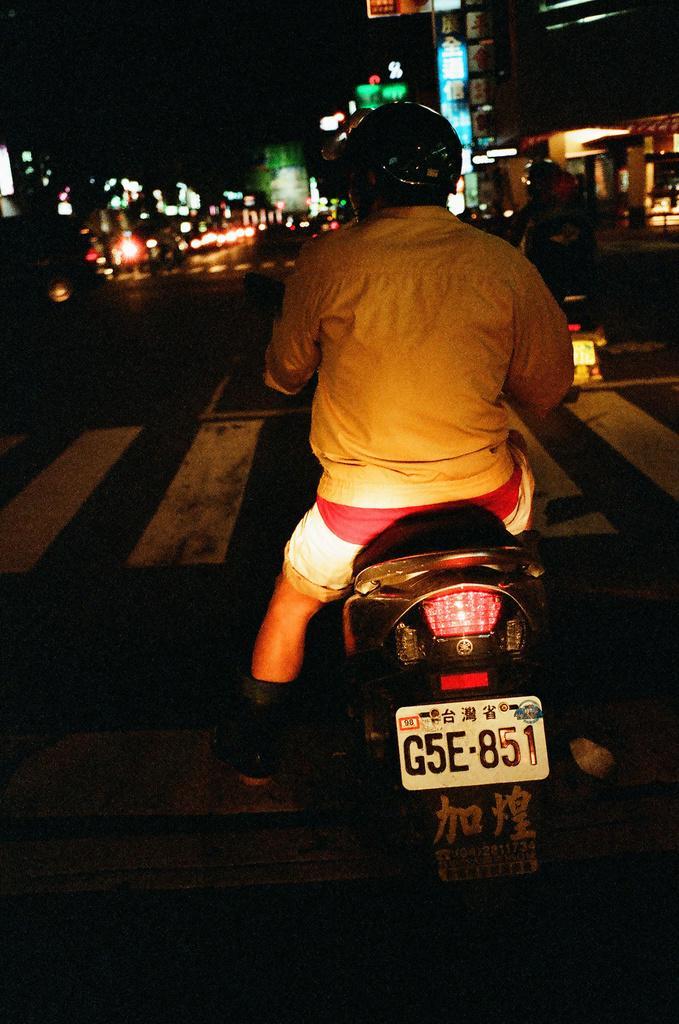In one or two sentences, can you explain what this image depicts? In this image we can see people sitting on the bikes. In the background there are lights and boards. On the right there is a building. At the bottom there is a road. 